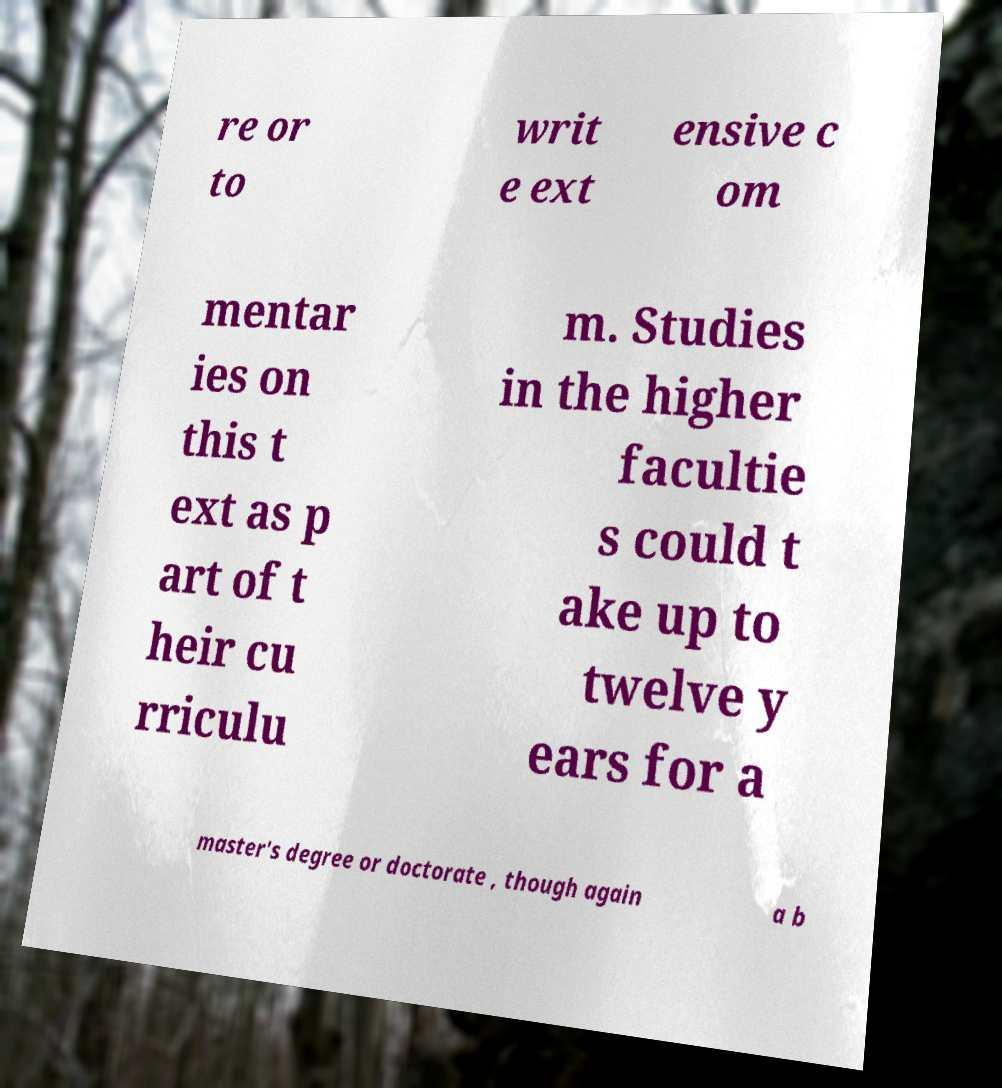Could you extract and type out the text from this image? re or to writ e ext ensive c om mentar ies on this t ext as p art of t heir cu rriculu m. Studies in the higher facultie s could t ake up to twelve y ears for a master's degree or doctorate , though again a b 